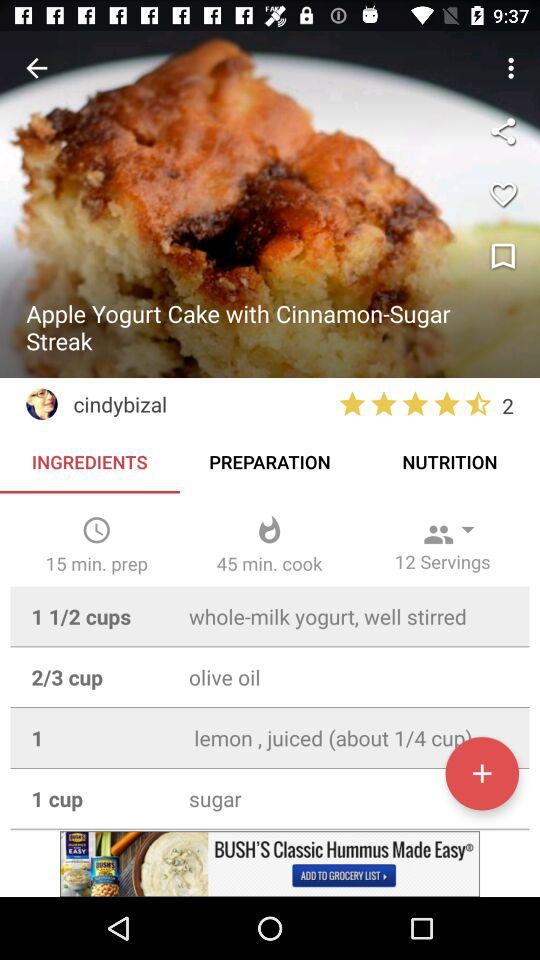How many servings does this recipe make?
Answer the question using a single word or phrase. 12 